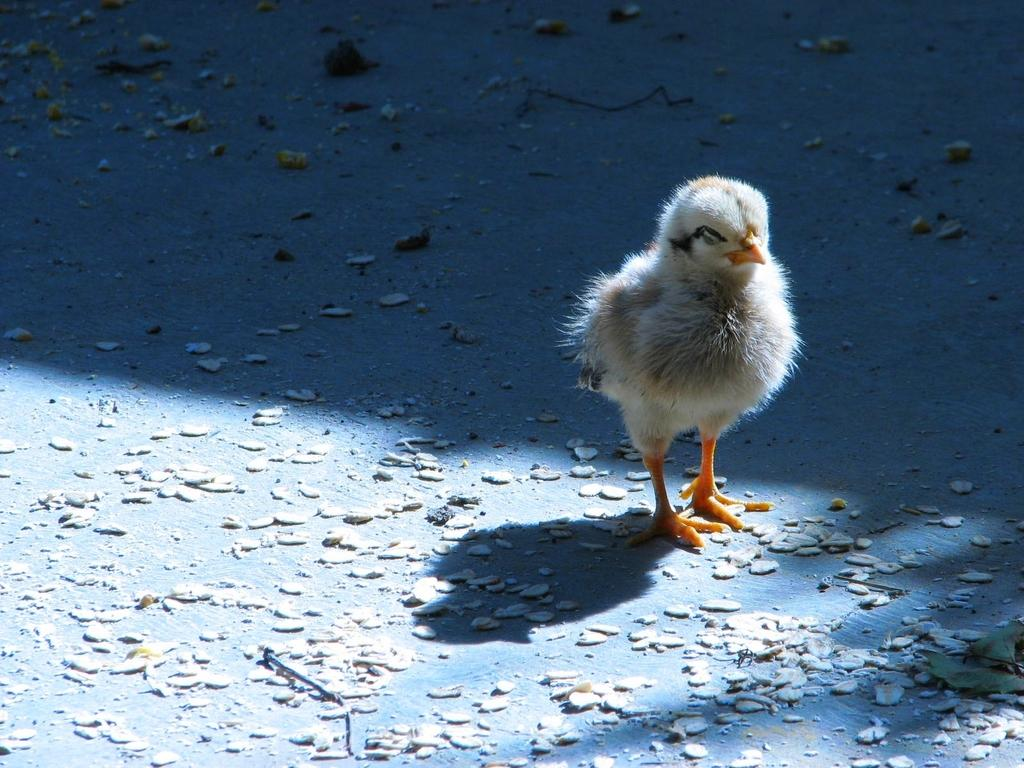What type of animal can be seen on the ground in the image? There is a bird on the ground in the image. What else can be seen in the image besides the bird? There are objects in the image. What level of the building is the bird on in the image? There is no indication of a building or any levels in the image; it only shows a bird on the ground. How many beds are visible in the image? There are no beds present in the image. 